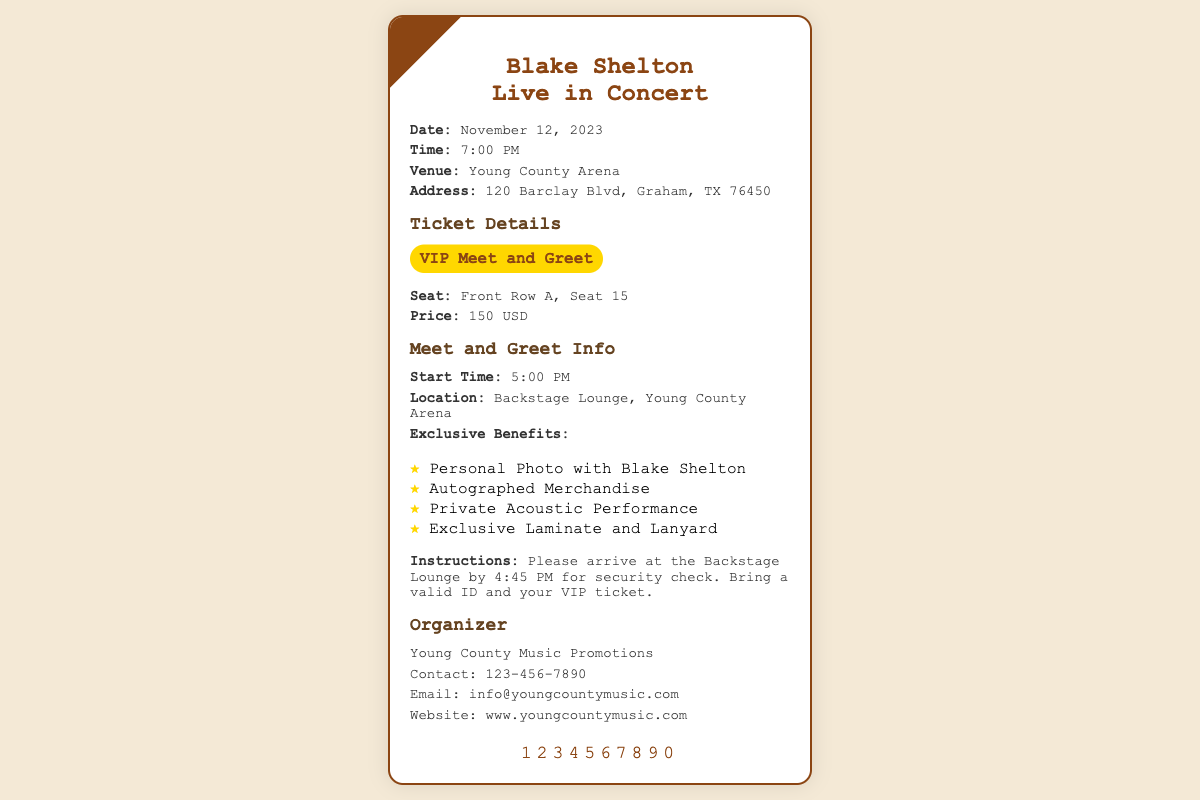What is the concert date? The concert date is explicitly stated in the document as November 12, 2023.
Answer: November 12, 2023 What time does the concert start? The document specifies the concert start time as 7:00 PM.
Answer: 7:00 PM What is the ticket price? The ticket price is provided in the ticket details as 150 USD.
Answer: 150 USD Where is the venue located? The address of the venue is mentioned in the document as 120 Barclay Blvd, Graham, TX 76450.
Answer: 120 Barclay Blvd, Graham, TX 76450 What are the exclusive benefits of the VIP meet and greet? The document lists several benefits, including "Personal Photo with Blake Shelton," highlighting the experience.
Answer: Personal Photo with Blake Shelton When should attendees arrive for the meet and greet? The instructions specify that attendees should arrive at 4:45 PM for the security check.
Answer: 4:45 PM What is the seating arrangement for the ticket holder? The seating arrangement is indicated as Front Row A, Seat 15 in the document.
Answer: Front Row A, Seat 15 What organization is promoting the concert? The organizer of the event is named as Young County Music Promotions in the ticket information.
Answer: Young County Music Promotions What is the contact number for the organizer? The contact number is provided in the document as 123-456-7890.
Answer: 123-456-7890 